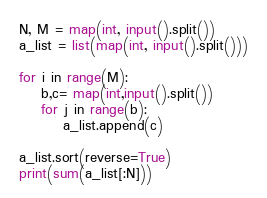<code> <loc_0><loc_0><loc_500><loc_500><_Python_>N, M = map(int, input().split())
a_list = list(map(int, input().split()))

for i in range(M):
    b,c= map(int,input().split())
    for j in range(b):
        a_list.append(c)

a_list.sort(reverse=True)
print(sum(a_list[:N]))</code> 